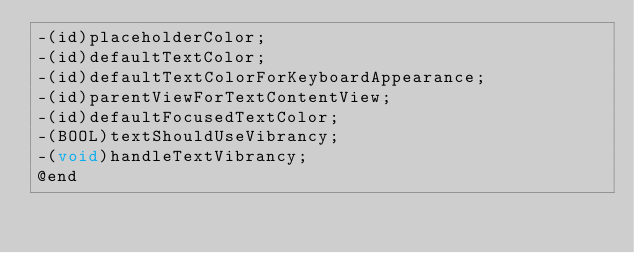Convert code to text. <code><loc_0><loc_0><loc_500><loc_500><_C_>-(id)placeholderColor;
-(id)defaultTextColor;
-(id)defaultTextColorForKeyboardAppearance;
-(id)parentViewForTextContentView;
-(id)defaultFocusedTextColor;
-(BOOL)textShouldUseVibrancy;
-(void)handleTextVibrancy;
@end

</code> 